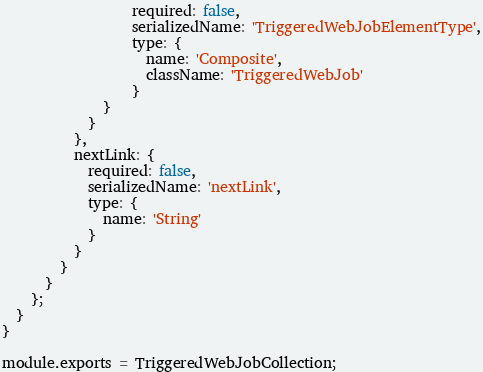Convert code to text. <code><loc_0><loc_0><loc_500><loc_500><_JavaScript_>                  required: false,
                  serializedName: 'TriggeredWebJobElementType',
                  type: {
                    name: 'Composite',
                    className: 'TriggeredWebJob'
                  }
              }
            }
          },
          nextLink: {
            required: false,
            serializedName: 'nextLink',
            type: {
              name: 'String'
            }
          }
        }
      }
    };
  }
}

module.exports = TriggeredWebJobCollection;
</code> 